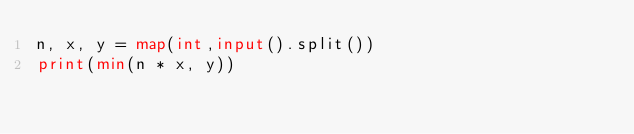Convert code to text. <code><loc_0><loc_0><loc_500><loc_500><_Python_>n, x, y = map(int,input().split())
print(min(n * x, y))</code> 